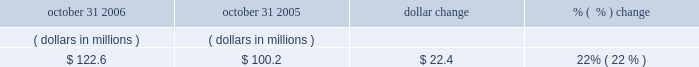Accounts receivable , net october 31 , 2006 october 31 , 2005 dollar change change .
The increase in accounts receivable was primarily due to the increased billings during the fiscal year ended october 31 , 2006 .
Days sales outstanding ( dso ) was 39 days at october 31 , 2006 and 36 days at october 31 , 2005 .
Our accounts receivable and dso are primarily driven by our billing and collections activities .
Net working capital working capital is comprised of current assets less current liabilities , as shown on our balance sheet .
As of october 31 , 2006 , our working capital was $ 23.4 million , compared to $ 130.6 million as of october 31 , 2005 .
The decrease in net working capital of $ 107.2 million was primarily due to ( 1 ) a decrease of $ 73.7 million in cash and cash equivalents ; ( 2 ) a decrease of current deferred tax assets of $ 83.2 million , primarily due to a tax accounting method change ; ( 3 ) a decrease in income taxes receivable of $ 5.8 million ; ( 4 ) an increase in income taxes payable of $ 21.5 million ; ( 5 ) an increase in deferred revenue of $ 29.9 million ; and ( 6 ) a net increase of $ 2.8 million in accounts payable and other liabilities which included a reclassification of debt of $ 7.5 million from long term to short term debt .
This decrease was partially offset by ( 1 ) an increase in short-term investments of $ 59.9 million ; ( 2 ) an increase in prepaid and other assets of $ 27.4 million , which includes land of $ 23.4 million reclassified from property plant and equipment to asset held for sale within prepaid expense and other assets on our consolidated balance sheet ; and ( 3 ) an increase in accounts receivable of $ 22.4 million .
Other commitments 2014revolving credit facility on october 20 , 2006 , we entered into a five-year , $ 300.0 million senior unsecured revolving credit facility providing for loans to synopsys and certain of its foreign subsidiaries .
The facility replaces our previous $ 250.0 million senior unsecured credit facility , which was terminated effective october 20 , 2006 .
The amount of the facility may be increased by up to an additional $ 150.0 million through the fourth year of the facility .
The facility contains financial covenants requiring us to maintain a minimum leverage ratio and specified levels of cash , as well as other non-financial covenants .
The facility terminates on october 20 , 2011 .
Borrowings under the facility bear interest at the greater of the administrative agent 2019s prime rate or the federal funds rate plus 0.50% ( 0.50 % ) ; however , we have the option to pay interest based on the outstanding amount at eurodollar rates plus a spread between 0.50% ( 0.50 % ) and 0.70% ( 0.70 % ) based on a pricing grid tied to a financial covenant .
In addition , commitment fees are payable on the facility at rates between 0.125% ( 0.125 % ) and 0.175% ( 0.175 % ) per year based on a pricing grid tied to a financial covenant .
As of october 31 , 2006 we had no outstanding borrowings under this credit facility and were in compliance with all the covenants .
We believe that our current cash , cash equivalents , short-term investments , cash generated from operations , and available credit under our credit facility will satisfy our business requirements for at least the next twelve months. .
Considering the years 2005-2006 , what is the variation observed in the working capital , in millions? 
Rationale: it is the difference between those values .
Computations: (130.6 - 23.4)
Answer: 107.2. 